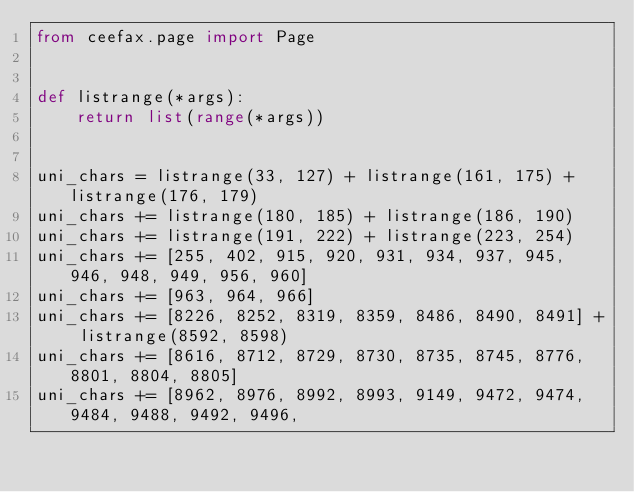<code> <loc_0><loc_0><loc_500><loc_500><_Python_>from ceefax.page import Page


def listrange(*args):
    return list(range(*args))


uni_chars = listrange(33, 127) + listrange(161, 175) + listrange(176, 179)
uni_chars += listrange(180, 185) + listrange(186, 190)
uni_chars += listrange(191, 222) + listrange(223, 254)
uni_chars += [255, 402, 915, 920, 931, 934, 937, 945, 946, 948, 949, 956, 960]
uni_chars += [963, 964, 966]
uni_chars += [8226, 8252, 8319, 8359, 8486, 8490, 8491] + listrange(8592, 8598)
uni_chars += [8616, 8712, 8729, 8730, 8735, 8745, 8776, 8801, 8804, 8805]
uni_chars += [8962, 8976, 8992, 8993, 9149, 9472, 9474, 9484, 9488, 9492, 9496,</code> 